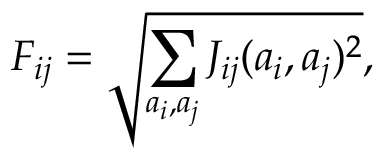<formula> <loc_0><loc_0><loc_500><loc_500>F _ { i j } = \sqrt { \sum _ { a _ { i } , a _ { j } } J _ { i j } ( a _ { i } , a _ { j } ) ^ { 2 } } ,</formula> 